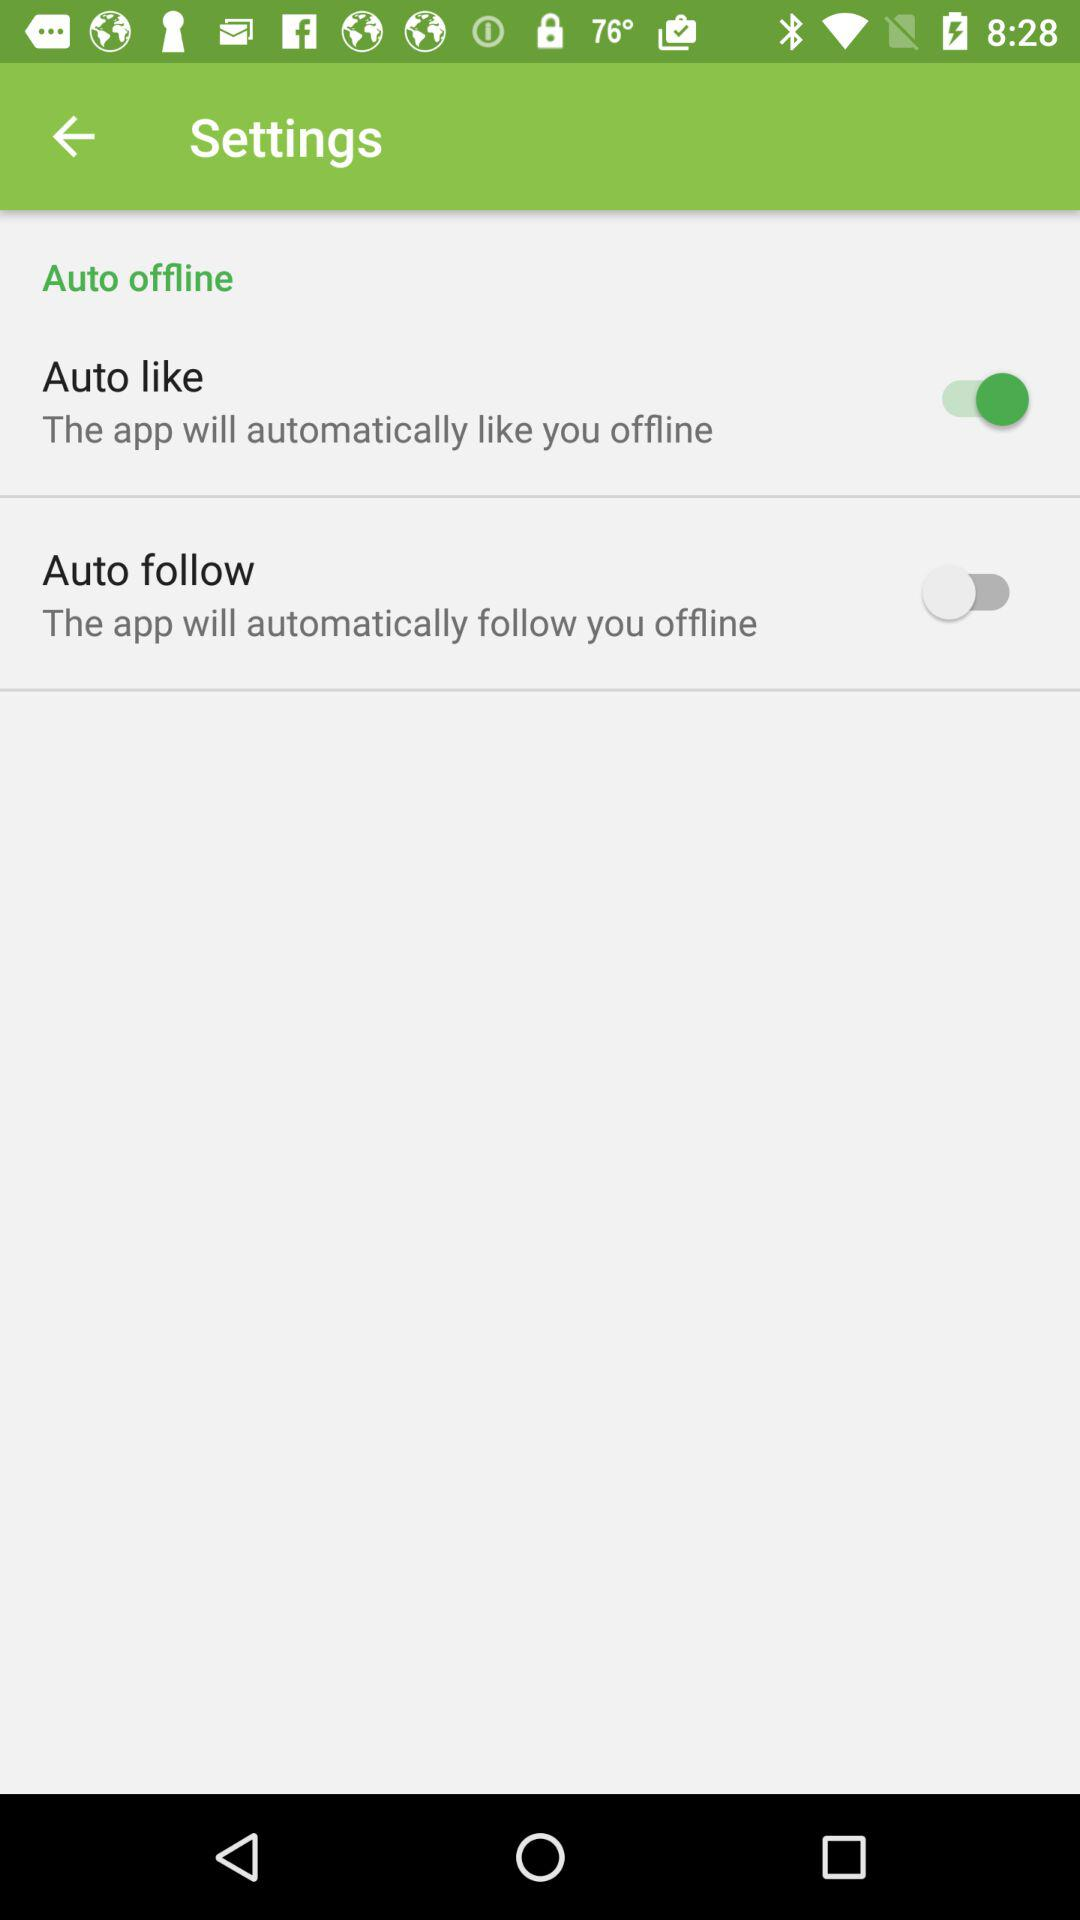What is the status of "Auto like"? The status of "Auto like" is "on". 